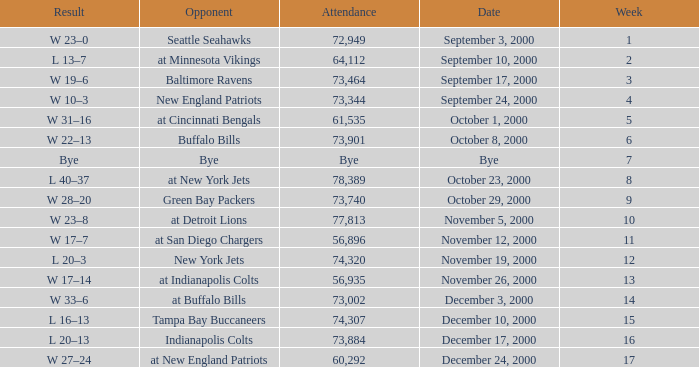What is the Result of the game with 72,949 in attendance? W 23–0. 